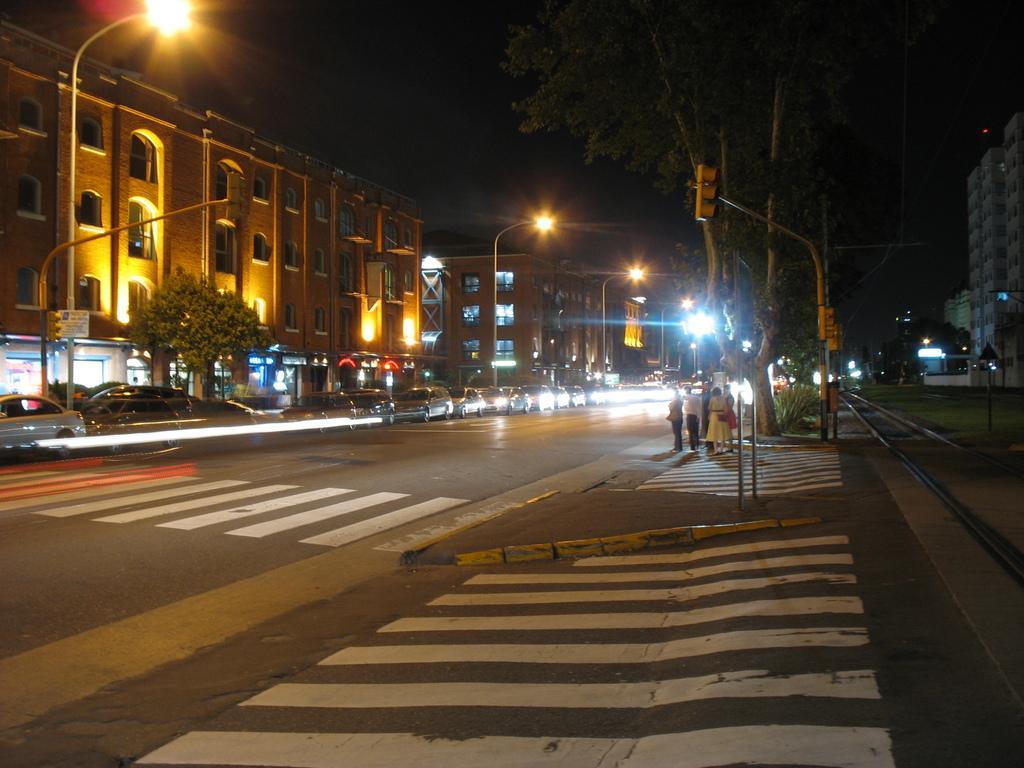Please provide a concise description of this image. In this picture I can see the vehicles on the road. I can see trees. I can see the buildings. I can see people. I can see the traffic light pole. I can see light poles. 